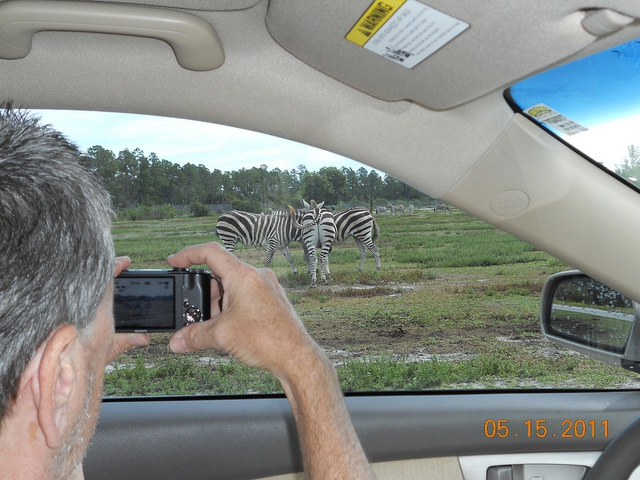Describe the objects in this image and their specific colors. I can see car in gray, darkgray, and lightgray tones, people in gray, darkgray, and tan tones, zebra in gray, darkgray, black, and lightgray tones, zebra in gray, darkgray, black, and lightgray tones, and zebra in gray, darkgray, and black tones in this image. 